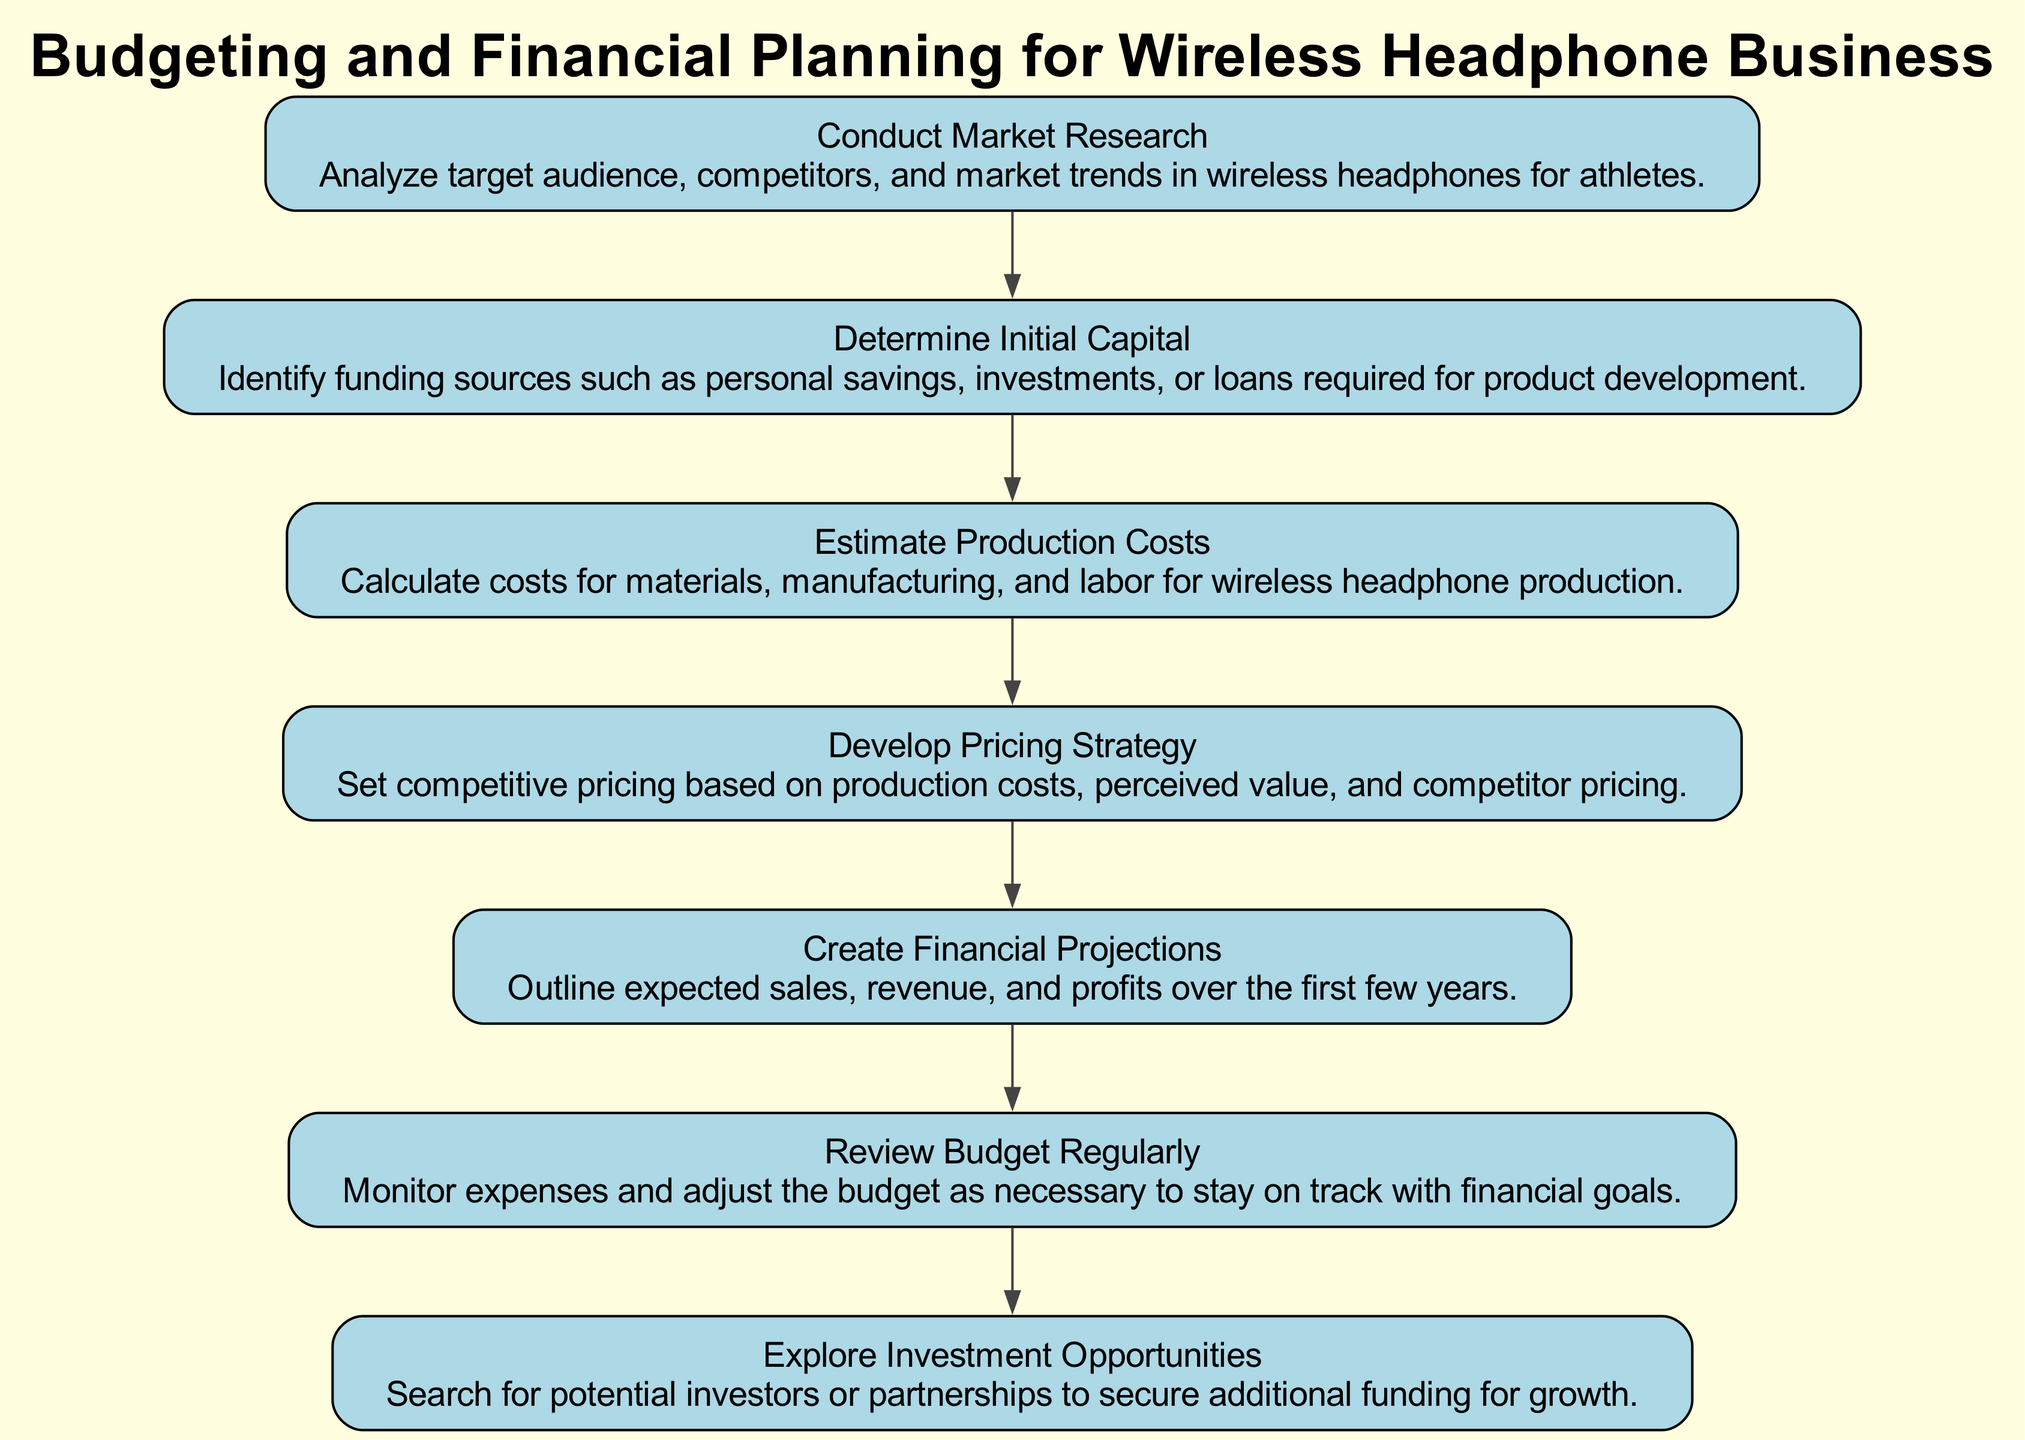What is the first step in the flow chart? The first step is "Conduct Market Research" as it is the topmost node in the diagram and starts the flow.
Answer: Conduct Market Research How many elements are there in the diagram? There are seven nodes in total, each representing a key step in budgeting and financial planning for the wireless headphone business.
Answer: Seven What follows after "Determine Initial Capital"? After "Determine Initial Capital," the next step is "Estimate Production Costs," which is connected directly to the initial capital node.
Answer: Estimate Production Costs What is the last step in the financial planning process? The final step in the flow chart is "Review Budget Regularly" as it is the last node that concludes the flow of the planning process.
Answer: Review Budget Regularly Which two steps are connected to "Develop Pricing Strategy"? The two steps connected to "Develop Pricing Strategy" are "Estimate Production Costs" and "Create Financial Projections," indicating a flow from production cost to pricing and then to projections.
Answer: Estimate Production Costs, Create Financial Projections How does the flow of the diagram progress from "Conduct Market Research" to "Explore Investment Opportunities"? The diagram progresses from "Conduct Market Research" through several steps: after conducting research, initial capital is determined, costs are estimated, a pricing strategy is developed, and then financial projections are made, which finally leads to exploring investment opportunities for growth.
Answer: Through six steps What is the purpose of "Create Financial Projections"? The purpose of this node is to outline expected sales, revenue, and profits over the first few years, providing a financial roadmap for the business.
Answer: Expected sales, revenue, and profits Which step involves analyzing competitors? The first step, "Conduct Market Research," involves analyzing competitors along with the target audience and market trends.
Answer: Conduct Market Research 